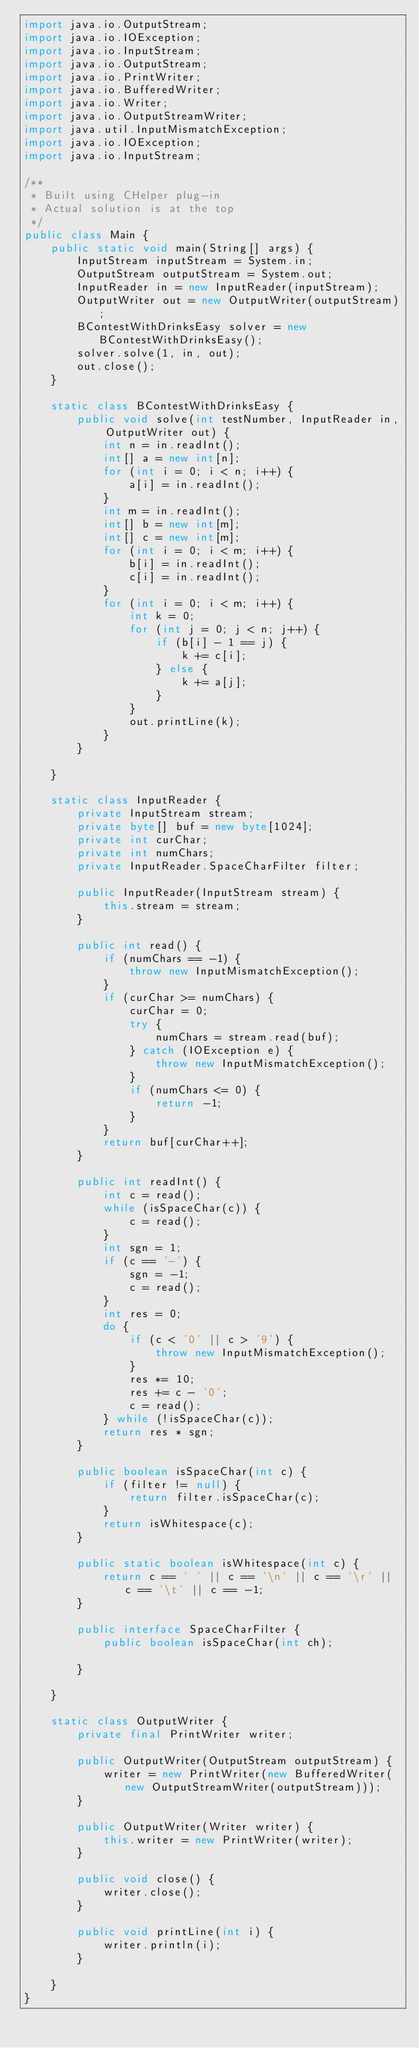<code> <loc_0><loc_0><loc_500><loc_500><_Java_>import java.io.OutputStream;
import java.io.IOException;
import java.io.InputStream;
import java.io.OutputStream;
import java.io.PrintWriter;
import java.io.BufferedWriter;
import java.io.Writer;
import java.io.OutputStreamWriter;
import java.util.InputMismatchException;
import java.io.IOException;
import java.io.InputStream;

/**
 * Built using CHelper plug-in
 * Actual solution is at the top
 */
public class Main {
    public static void main(String[] args) {
        InputStream inputStream = System.in;
        OutputStream outputStream = System.out;
        InputReader in = new InputReader(inputStream);
        OutputWriter out = new OutputWriter(outputStream);
        BContestWithDrinksEasy solver = new BContestWithDrinksEasy();
        solver.solve(1, in, out);
        out.close();
    }

    static class BContestWithDrinksEasy {
        public void solve(int testNumber, InputReader in, OutputWriter out) {
            int n = in.readInt();
            int[] a = new int[n];
            for (int i = 0; i < n; i++) {
                a[i] = in.readInt();
            }
            int m = in.readInt();
            int[] b = new int[m];
            int[] c = new int[m];
            for (int i = 0; i < m; i++) {
                b[i] = in.readInt();
                c[i] = in.readInt();
            }
            for (int i = 0; i < m; i++) {
                int k = 0;
                for (int j = 0; j < n; j++) {
                    if (b[i] - 1 == j) {
                        k += c[i];
                    } else {
                        k += a[j];
                    }
                }
                out.printLine(k);
            }
        }

    }

    static class InputReader {
        private InputStream stream;
        private byte[] buf = new byte[1024];
        private int curChar;
        private int numChars;
        private InputReader.SpaceCharFilter filter;

        public InputReader(InputStream stream) {
            this.stream = stream;
        }

        public int read() {
            if (numChars == -1) {
                throw new InputMismatchException();
            }
            if (curChar >= numChars) {
                curChar = 0;
                try {
                    numChars = stream.read(buf);
                } catch (IOException e) {
                    throw new InputMismatchException();
                }
                if (numChars <= 0) {
                    return -1;
                }
            }
            return buf[curChar++];
        }

        public int readInt() {
            int c = read();
            while (isSpaceChar(c)) {
                c = read();
            }
            int sgn = 1;
            if (c == '-') {
                sgn = -1;
                c = read();
            }
            int res = 0;
            do {
                if (c < '0' || c > '9') {
                    throw new InputMismatchException();
                }
                res *= 10;
                res += c - '0';
                c = read();
            } while (!isSpaceChar(c));
            return res * sgn;
        }

        public boolean isSpaceChar(int c) {
            if (filter != null) {
                return filter.isSpaceChar(c);
            }
            return isWhitespace(c);
        }

        public static boolean isWhitespace(int c) {
            return c == ' ' || c == '\n' || c == '\r' || c == '\t' || c == -1;
        }

        public interface SpaceCharFilter {
            public boolean isSpaceChar(int ch);

        }

    }

    static class OutputWriter {
        private final PrintWriter writer;

        public OutputWriter(OutputStream outputStream) {
            writer = new PrintWriter(new BufferedWriter(new OutputStreamWriter(outputStream)));
        }

        public OutputWriter(Writer writer) {
            this.writer = new PrintWriter(writer);
        }

        public void close() {
            writer.close();
        }

        public void printLine(int i) {
            writer.println(i);
        }

    }
}

</code> 